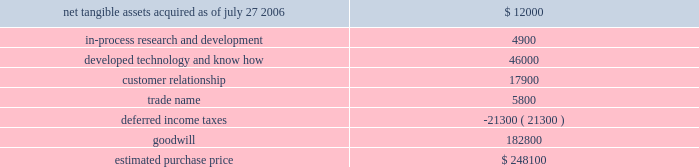Hologic , inc .
Notes to consolidated financial statements ( continued ) ( in thousands , except per share data ) the aggregate purchase price for suros of approximately $ 248000 ( subject to adjustment ) consisted of 2300 shares of hologic common stock valued at $ 106500 , cash paid of $ 139000 , and approximately $ 2600 for acquisition related fees and expenses .
The company determined the fair value of the shares issued in connection with the acquisition in accordance with eitf issue no .
99-12 , determination of the measurement date for the market price of acquirer securities issued in a purchase business combination .
The components and allocation of the purchase price , consists of the following approximate amounts: .
The acquisition also provides for a two-year earn out .
The earn-out will be payable in two annual cash installments equal to the incremental revenue growth in suros 2019 business in the two years following the closing .
The company has considered the provision of eitf issue no .
95-8 , accounting for contingent consideration paid to the shareholders of and acquired enterprise in a purchase business combination , and concluded that this contingent consideration represents additional purchase price .
As a result , goodwill will be increased by the amount of the additional consideration , if any , when it becomes due and payable .
As part of the purchase price allocation , all intangible assets that were a part of the acquisition were identified and valued .
It was determined that only customer lists , trademarks and developed technology had separately identifiable values .
Customer relationships represents suros large installed base that are expected to purchase disposable products on a regular basis .
Trademarks represent the suros product names that the company intends to continue to use .
Developed technology represents currently marketable purchased products that the company continues to resell as well as utilize to enhance and incorporate into the company 2019s existing products .
The estimated $ 4900 of purchase price allocated to in-process research and development projects primarily related to suros 2019 disposable products .
The projects are of various stages of completion and include next generation handpiece and site marker technologies .
The company expects that these projects will be completed during fiscal 2007 .
The deferred income tax liability relates to the tax effect of acquired identifiable intangible assets , and fair value adjustments to acquired inventory as such amounts are not deductible for tax purposes , partially offset by acquired net operating loss carry forwards that the company believes are realizable .
For all of the acquisitions discussed above , goodwill represents the excess of the purchase price over the net identifiable tangible and intangible assets acquired .
The company determined that the acquisition of each aeg , r2 and suros resulted in the recognition of goodwill primarily because of synergies unique to the company and the strength of its acquired workforce .
Supplemental pro-forma information the following unaudited pro forma information presents the consolidated results of operations of the company , r2 and suros as if the acquisitions had occurred at the beginning of each of fiscal 2006 and 2005 .
What percentage of the estimated purchase price is due to developed technology and know how? 
Computations: (46000 / 248100)
Answer: 0.18541. 